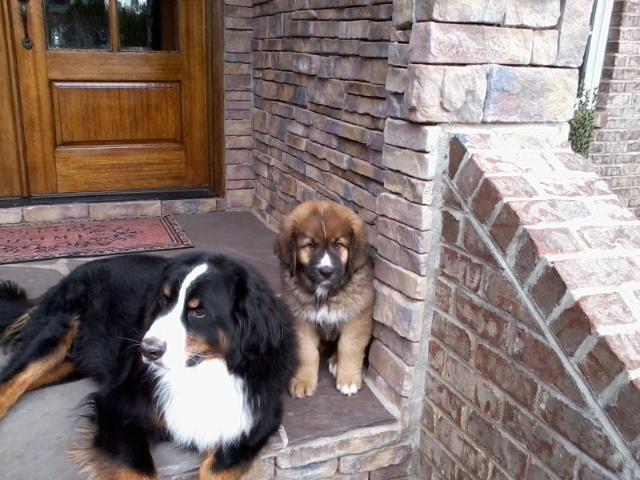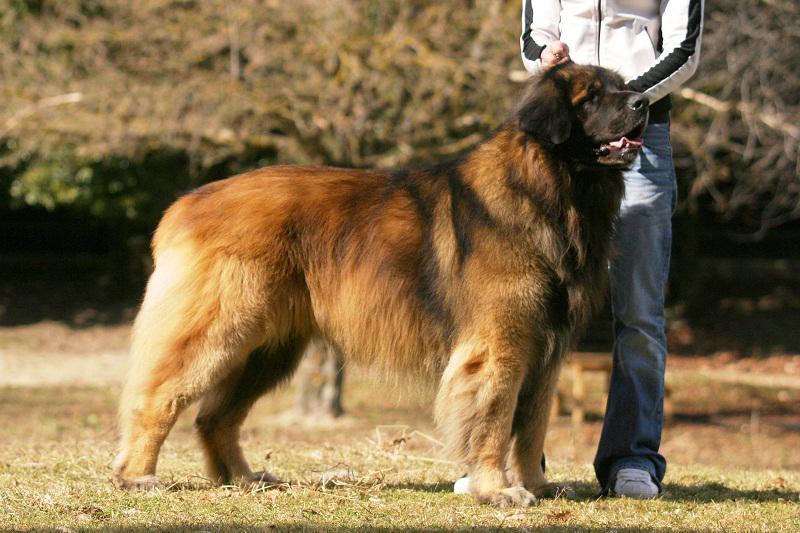The first image is the image on the left, the second image is the image on the right. Analyze the images presented: Is the assertion "There are exactly two dogs lying in the image on the right." valid? Answer yes or no. No. 